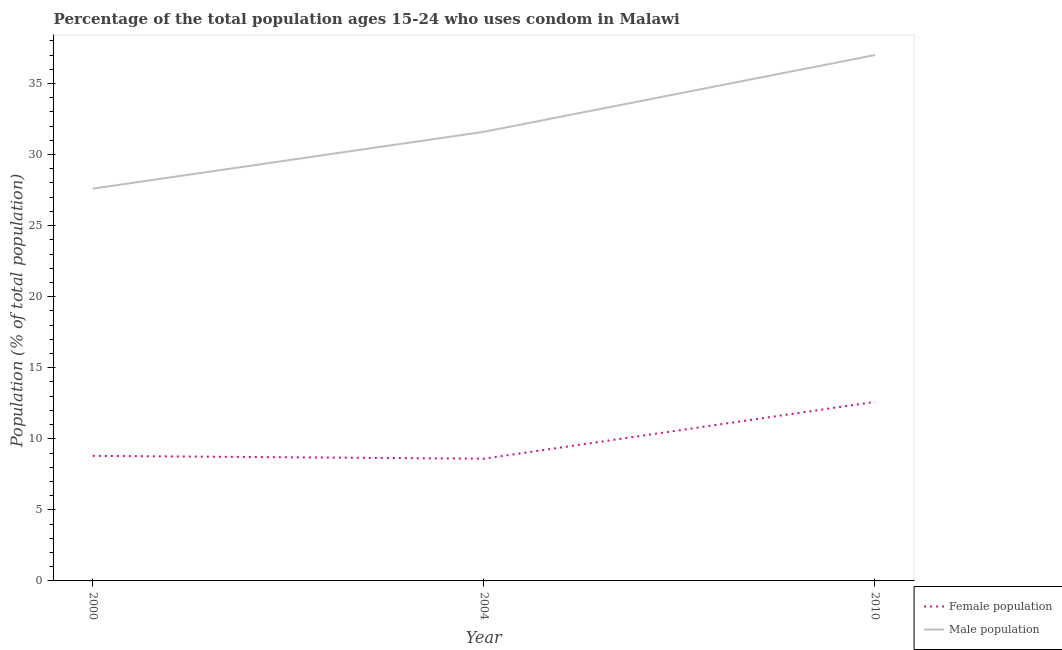How many different coloured lines are there?
Keep it short and to the point. 2. What is the male population in 2004?
Provide a short and direct response. 31.6. Across all years, what is the maximum male population?
Make the answer very short. 37. Across all years, what is the minimum male population?
Give a very brief answer. 27.6. In which year was the male population maximum?
Offer a terse response. 2010. What is the difference between the female population in 2000 and that in 2004?
Give a very brief answer. 0.2. What is the difference between the female population in 2004 and the male population in 2010?
Your answer should be compact. -28.4. In the year 2004, what is the difference between the male population and female population?
Your response must be concise. 23. What is the ratio of the female population in 2000 to that in 2010?
Offer a very short reply. 0.7. Is the female population in 2004 less than that in 2010?
Your answer should be very brief. Yes. What is the difference between the highest and the second highest female population?
Ensure brevity in your answer.  3.8. What is the difference between the highest and the lowest female population?
Keep it short and to the point. 4. In how many years, is the male population greater than the average male population taken over all years?
Provide a succinct answer. 1. Is the sum of the female population in 2000 and 2004 greater than the maximum male population across all years?
Ensure brevity in your answer.  No. Does the female population monotonically increase over the years?
Your response must be concise. No. Is the male population strictly greater than the female population over the years?
Make the answer very short. Yes. How many years are there in the graph?
Offer a very short reply. 3. Are the values on the major ticks of Y-axis written in scientific E-notation?
Keep it short and to the point. No. Does the graph contain any zero values?
Provide a succinct answer. No. Where does the legend appear in the graph?
Offer a terse response. Bottom right. How many legend labels are there?
Provide a succinct answer. 2. What is the title of the graph?
Ensure brevity in your answer.  Percentage of the total population ages 15-24 who uses condom in Malawi. What is the label or title of the Y-axis?
Ensure brevity in your answer.  Population (% of total population) . What is the Population (% of total population)  of Female population in 2000?
Provide a succinct answer. 8.8. What is the Population (% of total population)  of Male population in 2000?
Your answer should be compact. 27.6. What is the Population (% of total population)  of Male population in 2004?
Give a very brief answer. 31.6. What is the Population (% of total population)  of Female population in 2010?
Your response must be concise. 12.6. Across all years, what is the maximum Population (% of total population)  in Male population?
Offer a terse response. 37. Across all years, what is the minimum Population (% of total population)  of Male population?
Make the answer very short. 27.6. What is the total Population (% of total population)  in Male population in the graph?
Provide a short and direct response. 96.2. What is the difference between the Population (% of total population)  in Female population in 2000 and that in 2004?
Your answer should be compact. 0.2. What is the difference between the Population (% of total population)  of Male population in 2000 and that in 2004?
Your answer should be very brief. -4. What is the difference between the Population (% of total population)  in Male population in 2000 and that in 2010?
Provide a succinct answer. -9.4. What is the difference between the Population (% of total population)  of Male population in 2004 and that in 2010?
Give a very brief answer. -5.4. What is the difference between the Population (% of total population)  in Female population in 2000 and the Population (% of total population)  in Male population in 2004?
Provide a short and direct response. -22.8. What is the difference between the Population (% of total population)  of Female population in 2000 and the Population (% of total population)  of Male population in 2010?
Ensure brevity in your answer.  -28.2. What is the difference between the Population (% of total population)  in Female population in 2004 and the Population (% of total population)  in Male population in 2010?
Your answer should be compact. -28.4. What is the average Population (% of total population)  in Male population per year?
Your response must be concise. 32.07. In the year 2000, what is the difference between the Population (% of total population)  in Female population and Population (% of total population)  in Male population?
Provide a short and direct response. -18.8. In the year 2010, what is the difference between the Population (% of total population)  in Female population and Population (% of total population)  in Male population?
Provide a short and direct response. -24.4. What is the ratio of the Population (% of total population)  in Female population in 2000 to that in 2004?
Make the answer very short. 1.02. What is the ratio of the Population (% of total population)  of Male population in 2000 to that in 2004?
Offer a terse response. 0.87. What is the ratio of the Population (% of total population)  of Female population in 2000 to that in 2010?
Give a very brief answer. 0.7. What is the ratio of the Population (% of total population)  in Male population in 2000 to that in 2010?
Ensure brevity in your answer.  0.75. What is the ratio of the Population (% of total population)  in Female population in 2004 to that in 2010?
Your answer should be very brief. 0.68. What is the ratio of the Population (% of total population)  in Male population in 2004 to that in 2010?
Provide a succinct answer. 0.85. What is the difference between the highest and the second highest Population (% of total population)  in Male population?
Make the answer very short. 5.4. What is the difference between the highest and the lowest Population (% of total population)  of Female population?
Ensure brevity in your answer.  4. 